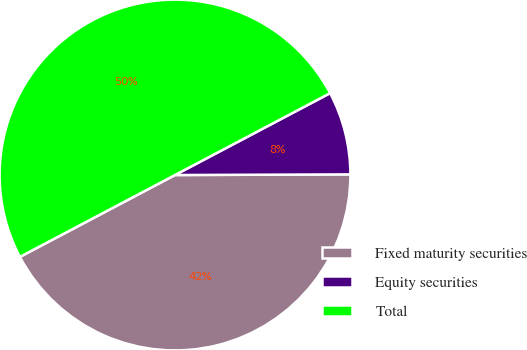<chart> <loc_0><loc_0><loc_500><loc_500><pie_chart><fcel>Fixed maturity securities<fcel>Equity securities<fcel>Total<nl><fcel>42.33%<fcel>7.67%<fcel>50.0%<nl></chart> 